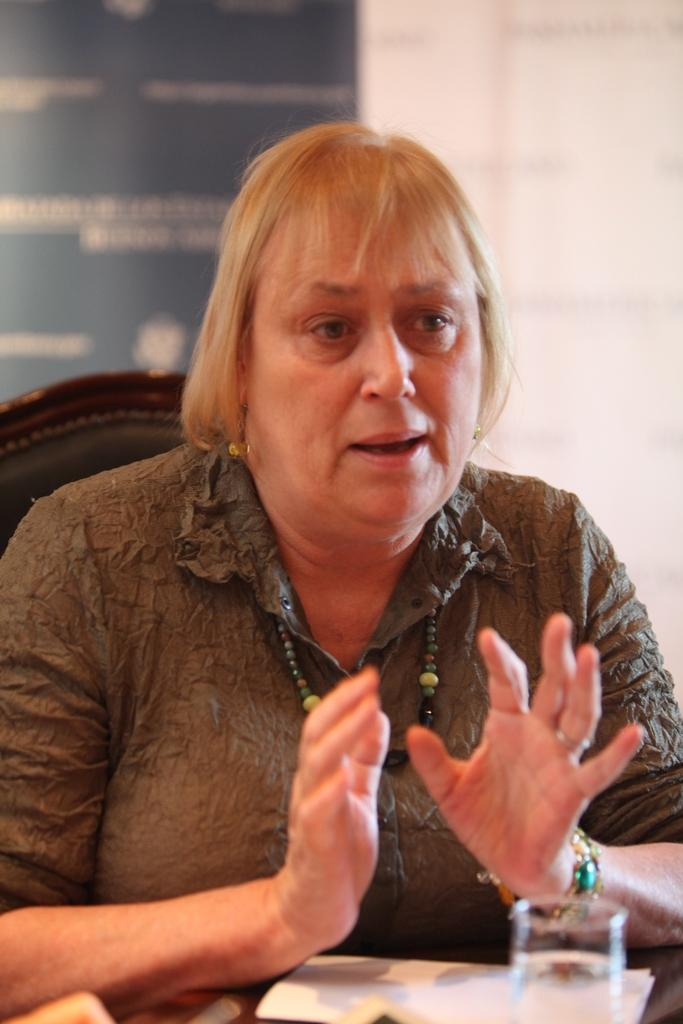Who is present in the image? There is a woman in the image. What is the woman wearing? The woman is wearing a dress. What is the woman doing in the image? The woman is sitting on a chair. What can be seen on the table in the image? There is glass on the table, as well as other unspecified items. What is the condition of the background in the image? The background of the image is blurred. How many bombs are visible on the table in the image? There are no bombs present in the image; the table contains glass and other unspecified items. What type of mountain can be seen in the background of the image? There is no mountain visible in the image; the background is blurred. 